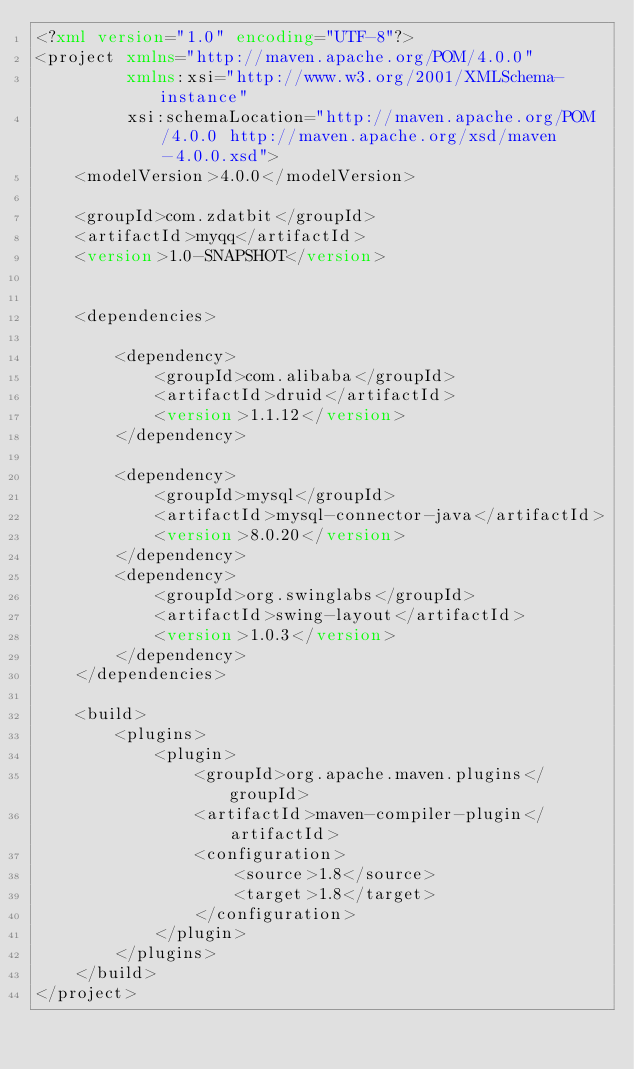<code> <loc_0><loc_0><loc_500><loc_500><_XML_><?xml version="1.0" encoding="UTF-8"?>
<project xmlns="http://maven.apache.org/POM/4.0.0"
         xmlns:xsi="http://www.w3.org/2001/XMLSchema-instance"
         xsi:schemaLocation="http://maven.apache.org/POM/4.0.0 http://maven.apache.org/xsd/maven-4.0.0.xsd">
    <modelVersion>4.0.0</modelVersion>

    <groupId>com.zdatbit</groupId>
    <artifactId>myqq</artifactId>
    <version>1.0-SNAPSHOT</version>


    <dependencies>

        <dependency>
            <groupId>com.alibaba</groupId>
            <artifactId>druid</artifactId>
            <version>1.1.12</version>
        </dependency>

        <dependency>
            <groupId>mysql</groupId>
            <artifactId>mysql-connector-java</artifactId>
            <version>8.0.20</version>
        </dependency>
        <dependency>
            <groupId>org.swinglabs</groupId>
            <artifactId>swing-layout</artifactId>
            <version>1.0.3</version>
        </dependency>
    </dependencies>

    <build>
        <plugins>
            <plugin>
                <groupId>org.apache.maven.plugins</groupId>
                <artifactId>maven-compiler-plugin</artifactId>
                <configuration>
                    <source>1.8</source>
                    <target>1.8</target>
                </configuration>
            </plugin>
        </plugins>
    </build>
</project></code> 